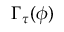<formula> <loc_0><loc_0><loc_500><loc_500>\Gamma _ { \tau } ( \phi )</formula> 